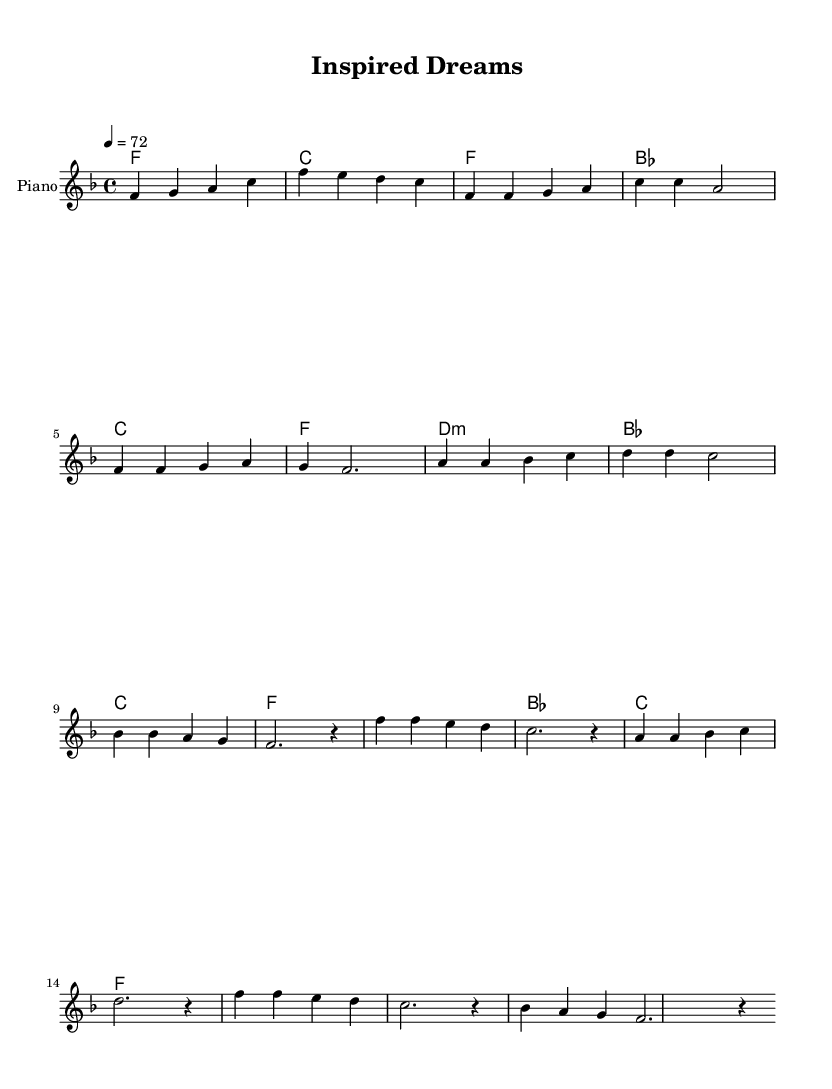What is the key signature of this music? The key signature shows one flat, indicating that the music is in F major.
Answer: F major What is the time signature of this piece? The time signature displayed at the beginning is 4/4, which means there are four beats per measure.
Answer: 4/4 What is the tempo marking for this piece? The tempo marking indicates a speed of 72 beats per minute, as shown by the notation.
Answer: 72 How many measures are in the chorus section? By analyzing the sheet music, the chorus section consists of four measures as counted from the beginning and noting the repeated pattern.
Answer: 4 What is the first chord played in the introduction? The first chord indicated in the introduction is F, which is shown as the first chord sign.
Answer: F What is the relationship between the pre-chorus and the chorus? The pre-chorus leads into the chorus and shares similar melodic notes, creating a smooth transition into the main theme. This is seen as the last note of the pre-chorus matches the first note of the chorus.
Answer: Smooth transition How does the harmony support the melody in this piece? The harmony underpins the melody by providing chordal support throughout each section, enhancing the emotional depth. Specifically, the chords change to match the melodic shifts, providing a fuller sound, especially during the chorus.
Answer: Emotional depth 